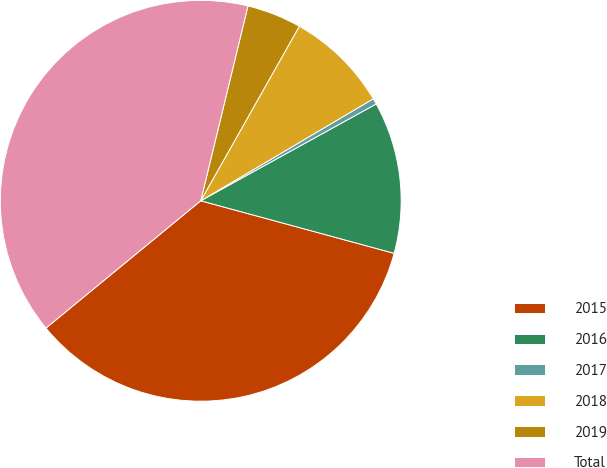<chart> <loc_0><loc_0><loc_500><loc_500><pie_chart><fcel>2015<fcel>2016<fcel>2017<fcel>2018<fcel>2019<fcel>Total<nl><fcel>34.82%<fcel>12.25%<fcel>0.47%<fcel>8.32%<fcel>4.4%<fcel>39.74%<nl></chart> 